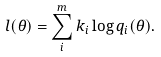Convert formula to latex. <formula><loc_0><loc_0><loc_500><loc_500>l ( \theta ) = \sum _ { i } ^ { m } k _ { i } \log q _ { i } ( \theta ) .</formula> 